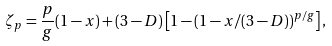Convert formula to latex. <formula><loc_0><loc_0><loc_500><loc_500>\zeta _ { p } = \frac { p } { g } ( 1 - x ) + ( 3 - D ) \left [ 1 - ( 1 - x / ( 3 - D ) ) ^ { p / g } \right ] ,</formula> 